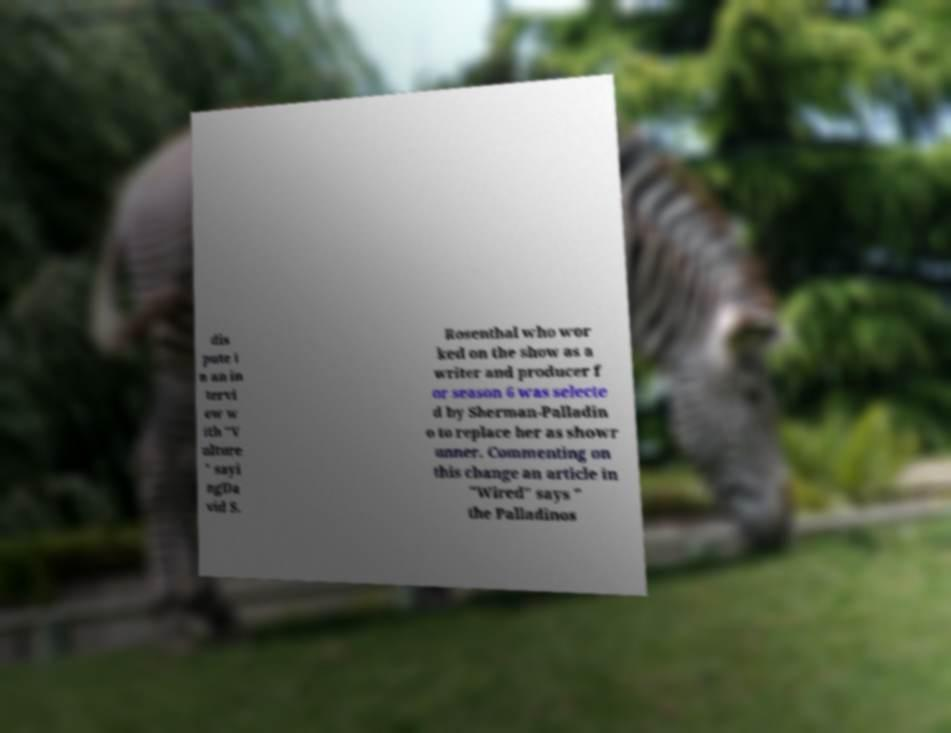Please read and relay the text visible in this image. What does it say? dis pute i n an in tervi ew w ith "V ulture " sayi ngDa vid S. Rosenthal who wor ked on the show as a writer and producer f or season 6 was selecte d by Sherman-Palladin o to replace her as showr unner. Commenting on this change an article in "Wired" says " the Palladinos 